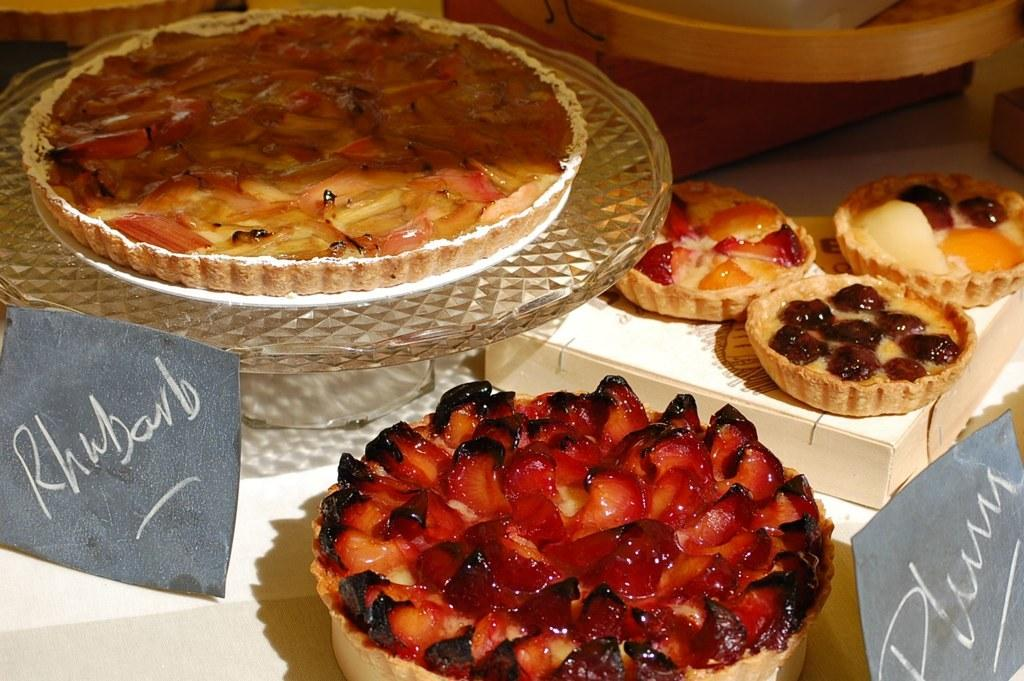What type of items can be seen in the image? There are food items in the image. What colors are the food items? The food items are in red, cream, brown, and orange colors. How are the food items arranged in the image? The food items are in a bowl. What is the color of the surface the bowl is placed on? The bowl is on a white surface. How many beams of sunlight are shining on the food items in the image? There is no mention of beams of sunlight in the image; it only describes the colors and arrangement of the food items. 